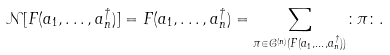Convert formula to latex. <formula><loc_0><loc_0><loc_500><loc_500>\mathcal { N } [ F ( a _ { 1 } , \dots , a _ { n } ^ { \dag } ) ] = F ( a _ { 1 } , \dots , a _ { n } ^ { \dag } ) = \sum _ { \pi \in \mathcal { C } ^ { ( n ) } ( F ( a _ { 1 } , \dots , a _ { n } ^ { \dag } ) ) } \colon \pi \colon .</formula> 